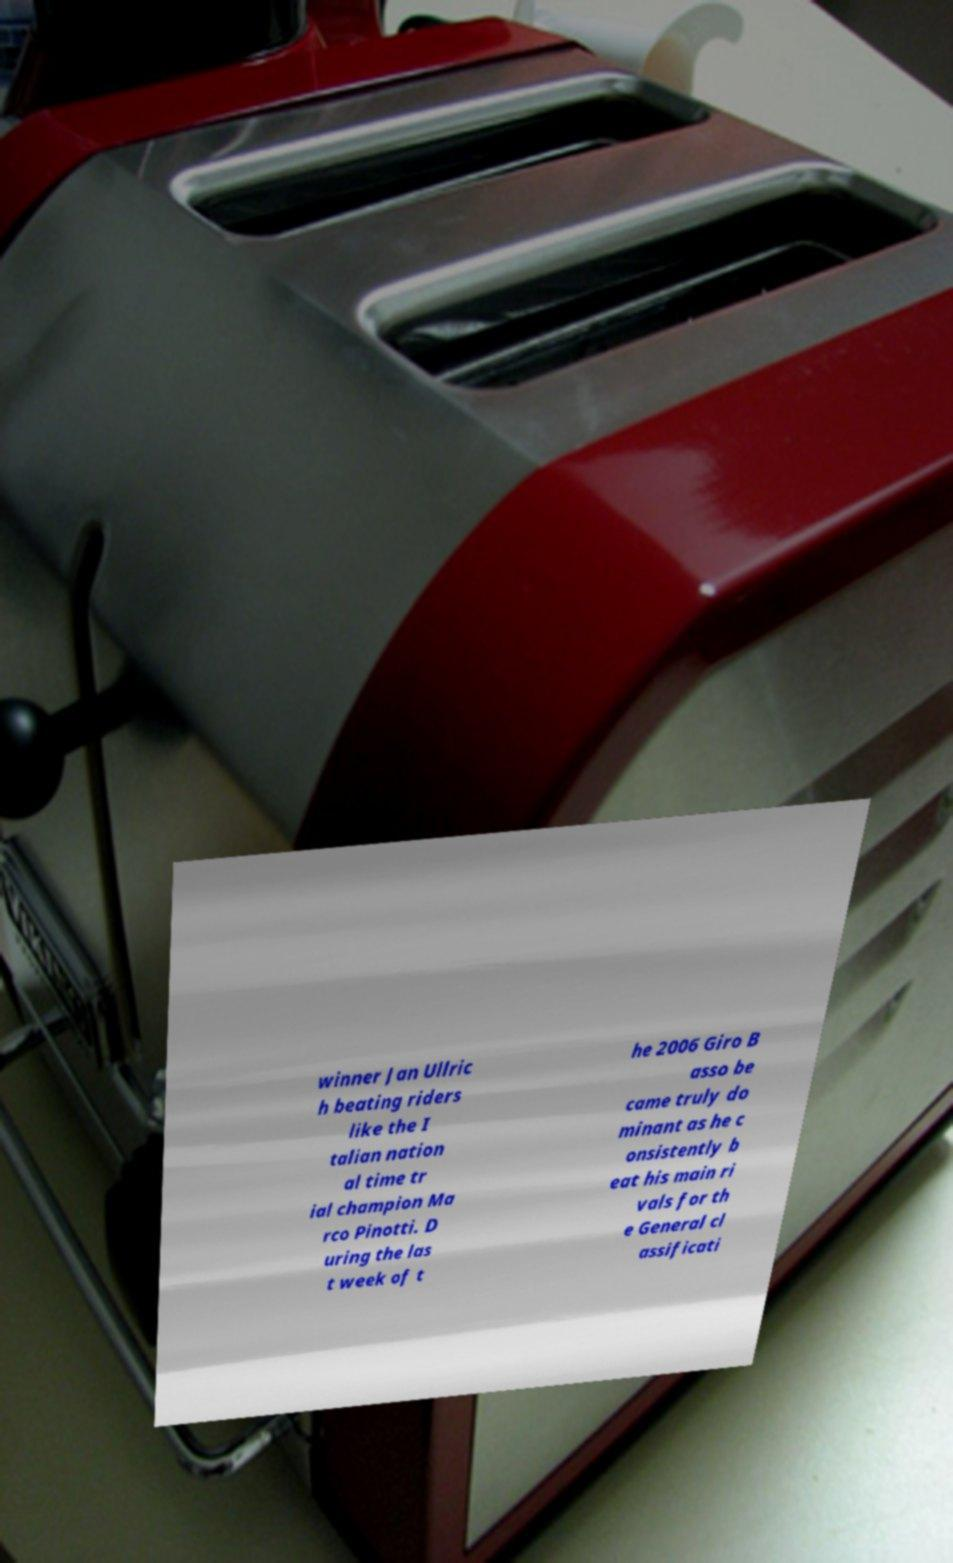Could you extract and type out the text from this image? winner Jan Ullric h beating riders like the I talian nation al time tr ial champion Ma rco Pinotti. D uring the las t week of t he 2006 Giro B asso be came truly do minant as he c onsistently b eat his main ri vals for th e General cl assificati 